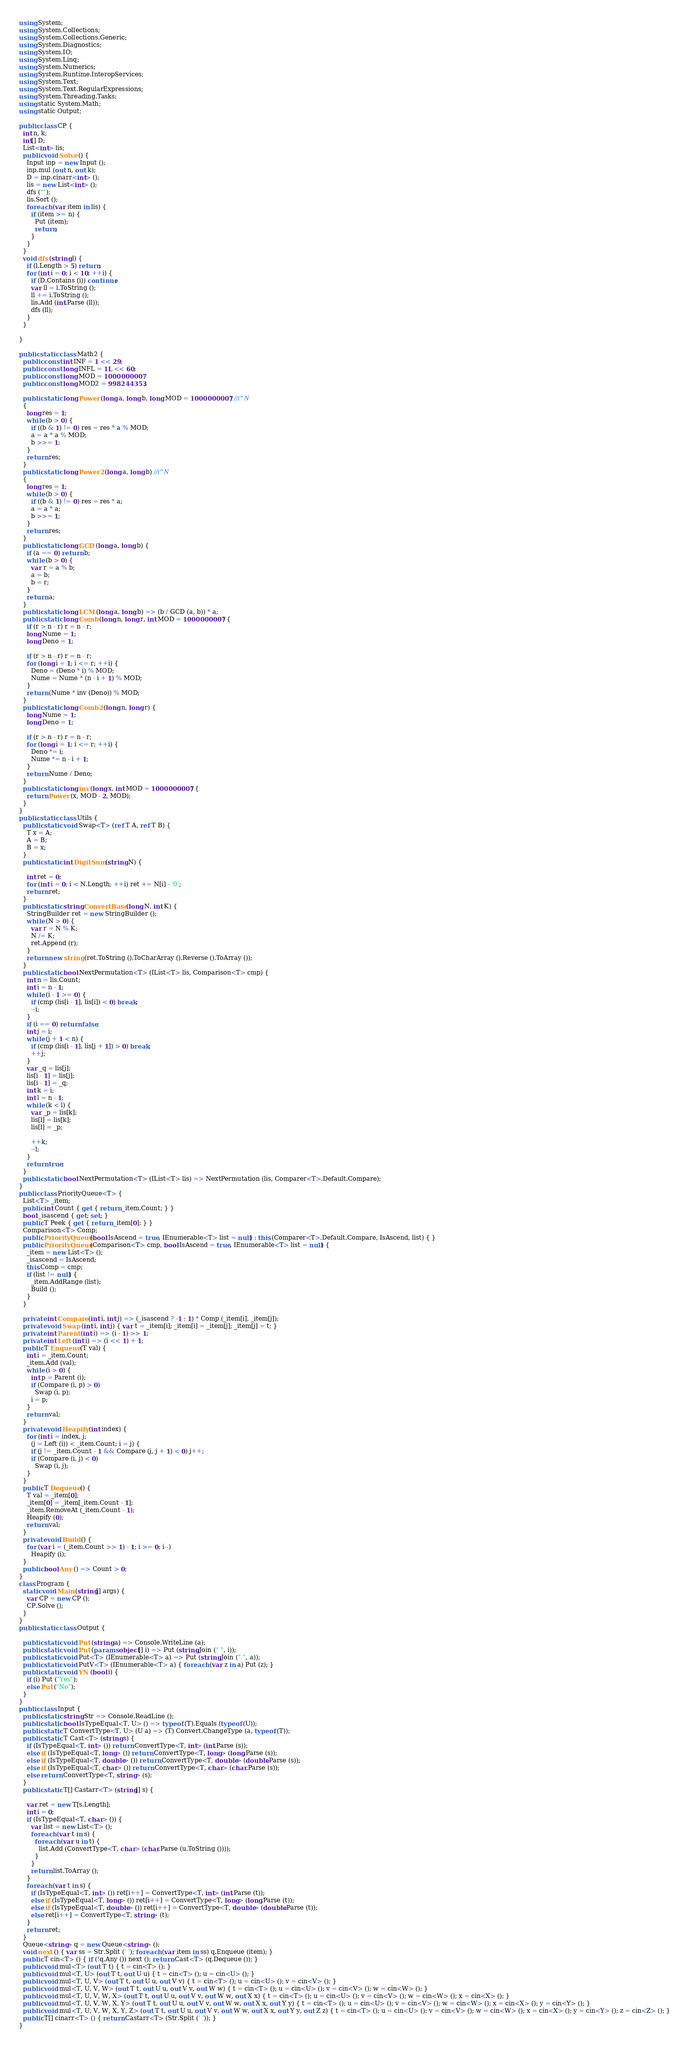<code> <loc_0><loc_0><loc_500><loc_500><_C#_>using System;
using System.Collections;
using System.Collections.Generic;
using System.Diagnostics;
using System.IO;
using System.Linq;
using System.Numerics;
using System.Runtime.InteropServices;
using System.Text;
using System.Text.RegularExpressions;
using System.Threading.Tasks;
using static System.Math;
using static Output;

public class CP {
  int n, k;
  int[] D;
  List<int> lis;
  public void Solve () {
    Input inp = new Input ();
    inp.mul (out n, out k);
    D = inp.cinarr<int> ();
    lis = new List<int> ();
    dfs ("");
    lis.Sort ();
    foreach (var item in lis) {
      if (item >= n) {
        Put (item);
        return;
      }
    }
  }
  void dfs (string l) {
    if (l.Length > 5) return;
    for (int i = 0; i < 10; ++i) {
      if (D.Contains (i)) continue;
      var ll = l.ToString ();
      ll += i.ToString ();
      lis.Add (int.Parse (ll));
      dfs (ll);
    }
  }

}

public static class Math2 {
  public const int INF = 1 << 29;
  public const long INFL = 1L << 60;
  public const long MOD = 1000000007;
  public const long MOD2 = 998244353;

  public static long Power (long a, long b, long MOD = 1000000007) //i^N
  {
    long res = 1;
    while (b > 0) {
      if ((b & 1) != 0) res = res * a % MOD;
      a = a * a % MOD;
      b >>= 1;
    }
    return res;
  }
  public static long Power2 (long a, long b) //i^N
  {
    long res = 1;
    while (b > 0) {
      if ((b & 1) != 0) res = res * a;
      a = a * a;
      b >>= 1;
    }
    return res;
  }
  public static long GCD (long a, long b) {
    if (a == 0) return b;
    while (b > 0) {
      var r = a % b;
      a = b;
      b = r;
    }
    return a;
  }
  public static long LCM (long a, long b) => (b / GCD (a, b)) * a;
  public static long Comb (long n, long r, int MOD = 1000000007) {
    if (r > n - r) r = n - r;
    long Nume = 1;
    long Deno = 1;

    if (r > n - r) r = n - r;
    for (long i = 1; i <= r; ++i) {
      Deno = (Deno * i) % MOD;
      Nume = Nume * (n - i + 1) % MOD;
    }
    return (Nume * inv (Deno)) % MOD;
  }
  public static long Comb2 (long n, long r) {
    long Nume = 1;
    long Deno = 1;

    if (r > n - r) r = n - r;
    for (long i = 1; i <= r; ++i) {
      Deno *= i;
      Nume *= n - i + 1;
    }
    return Nume / Deno;
  }
  public static long inv (long x, int MOD = 1000000007) {
    return Power (x, MOD - 2, MOD);
  }
}
public static class Utils {
  public static void Swap<T> (ref T A, ref T B) {
    T x = A;
    A = B;
    B = x;
  }
  public static int DigitSum (string N) {

    int ret = 0;
    for (int i = 0; i < N.Length; ++i) ret += N[i] - '0';
    return ret;
  }
  public static string ConvertBase (long N, int K) {
    StringBuilder ret = new StringBuilder ();
    while (N > 0) {
      var r = N % K;
      N /= K;
      ret.Append (r);
    }
    return new string (ret.ToString ().ToCharArray ().Reverse ().ToArray ());
  }
  public static bool NextPermutation<T> (IList<T> lis, Comparison<T> cmp) {
    int n = lis.Count;
    int i = n - 1;
    while (i - 1 >= 0) {
      if (cmp (lis[i - 1], lis[i]) < 0) break;
      --i;
    }
    if (i == 0) return false;
    int j = i;
    while (j + 1 < n) {
      if (cmp (lis[i - 1], lis[j + 1]) > 0) break;
      ++j;
    }
    var _q = lis[j];
    lis[i - 1] = lis[j];
    lis[i - 1] = _q;
    int k = i;
    int l = n - 1;
    while (k < l) {
      var _p = lis[k];
      lis[l] = lis[k];
      lis[l] = _p;

      ++k;
      --l;
    }
    return true;
  }
  public static bool NextPermutation<T> (IList<T> lis) => NextPermutation (lis, Comparer<T>.Default.Compare);
}
public class PriorityQueue<T> {
  List<T> _item;
  public int Count { get { return _item.Count; } }
  bool _isascend { get; set; }
  public T Peek { get { return _item[0]; } }
  Comparison<T> Comp;
  public PriorityQueue (bool IsAscend = true, IEnumerable<T> list = null) : this (Comparer<T>.Default.Compare, IsAscend, list) { }
  public PriorityQueue (Comparison<T> cmp, bool IsAscend = true, IEnumerable<T> list = null) {
    _item = new List<T> ();
    _isascend = IsAscend;
    this.Comp = cmp;
    if (list != null) {
      _item.AddRange (list);
      Build ();
    }
  }

  private int Compare (int i, int j) => (_isascend ? -1 : 1) * Comp (_item[i], _item[j]);
  private void Swap (int i, int j) { var t = _item[i]; _item[i] = _item[j]; _item[j] = t; }
  private int Parent (int i) => (i - 1) >> 1;
  private int Left (int i) => (i << 1) + 1;
  public T Enqueue (T val) {
    int i = _item.Count;
    _item.Add (val);
    while (i > 0) {
      int p = Parent (i);
      if (Compare (i, p) > 0)
        Swap (i, p);
      i = p;
    }
    return val;
  }
  private void Heapify (int index) {
    for (int i = index, j;
      (j = Left (i)) < _item.Count; i = j) {
      if (j != _item.Count - 1 && Compare (j, j + 1) < 0) j++;
      if (Compare (i, j) < 0)
        Swap (i, j);
    }
  }
  public T Dequeue () {
    T val = _item[0];
    _item[0] = _item[_item.Count - 1];
    _item.RemoveAt (_item.Count - 1);
    Heapify (0);
    return val;
  }
  private void Build () {
    for (var i = (_item.Count >> 1) - 1; i >= 0; i--)
      Heapify (i);
  }
  public bool Any () => Count > 0;
}
class Program {
  static void Main (string[] args) {
    var CP = new CP ();
    CP.Solve ();
  }
}
public static class Output {

  public static void Put (string a) => Console.WriteLine (a);
  public static void Put (params object[] i) => Put (string.Join (" ", i));
  public static void Put<T> (IEnumerable<T> a) => Put (string.Join (" ", a));
  public static void PutV<T> (IEnumerable<T> a) { foreach (var z in a) Put (z); }
  public static void YN (bool i) {
    if (i) Put ("Yes");
    else Put ("No");
  }
}
public class Input {
  public static string Str => Console.ReadLine ();
  public static bool IsTypeEqual<T, U> () => typeof (T).Equals (typeof (U));
  public static T ConvertType<T, U> (U a) => (T) Convert.ChangeType (a, typeof (T));
  public static T Cast<T> (string s) {
    if (IsTypeEqual<T, int> ()) return ConvertType<T, int> (int.Parse (s));
    else if (IsTypeEqual<T, long> ()) return ConvertType<T, long> (long.Parse (s));
    else if (IsTypeEqual<T, double> ()) return ConvertType<T, double> (double.Parse (s));
    else if (IsTypeEqual<T, char> ()) return ConvertType<T, char> (char.Parse (s));
    else return ConvertType<T, string> (s);
  }
  public static T[] Castarr<T> (string[] s) {

    var ret = new T[s.Length];
    int i = 0;
    if (IsTypeEqual<T, char> ()) {
      var list = new List<T> ();
      foreach (var t in s) {
        foreach (var u in t) {
          list.Add (ConvertType<T, char> (char.Parse (u.ToString ())));
        }
      }
      return list.ToArray ();
    }
    foreach (var t in s) {
      if (IsTypeEqual<T, int> ()) ret[i++] = ConvertType<T, int> (int.Parse (t));
      else if (IsTypeEqual<T, long> ()) ret[i++] = ConvertType<T, long> (long.Parse (t));
      else if (IsTypeEqual<T, double> ()) ret[i++] = ConvertType<T, double> (double.Parse (t));
      else ret[i++] = ConvertType<T, string> (t);
    }
    return ret;
  }
  Queue<string> q = new Queue<string> ();
  void next () { var ss = Str.Split (' '); foreach (var item in ss) q.Enqueue (item); }
  public T cin<T> () { if (!q.Any ()) next (); return Cast<T> (q.Dequeue ()); }
  public void mul<T> (out T t) { t = cin<T> (); }
  public void mul<T, U> (out T t, out U u) { t = cin<T> (); u = cin<U> (); }
  public void mul<T, U, V> (out T t, out U u, out V v) { t = cin<T> (); u = cin<U> (); v = cin<V> (); }
  public void mul<T, U, V, W> (out T t, out U u, out V v, out W w) { t = cin<T> (); u = cin<U> (); v = cin<V> (); w = cin<W> (); }
  public void mul<T, U, V, W, X> (out T t, out U u, out V v, out W w, out X x) { t = cin<T> (); u = cin<U> (); v = cin<V> (); w = cin<W> (); x = cin<X> (); }
  public void mul<T, U, V, W, X, Y> (out T t, out U u, out V v, out W w, out X x, out Y y) { t = cin<T> (); u = cin<U> (); v = cin<V> (); w = cin<W> (); x = cin<X> (); y = cin<Y> (); }
  public void mul<T, U, V, W, X, Y, Z> (out T t, out U u, out V v, out W w, out X x, out Y y, out Z z) { t = cin<T> (); u = cin<U> (); v = cin<V> (); w = cin<W> (); x = cin<X> (); y = cin<Y> (); z = cin<Z> (); }
  public T[] cinarr<T> () { return Castarr<T> (Str.Split (' ')); }
}</code> 